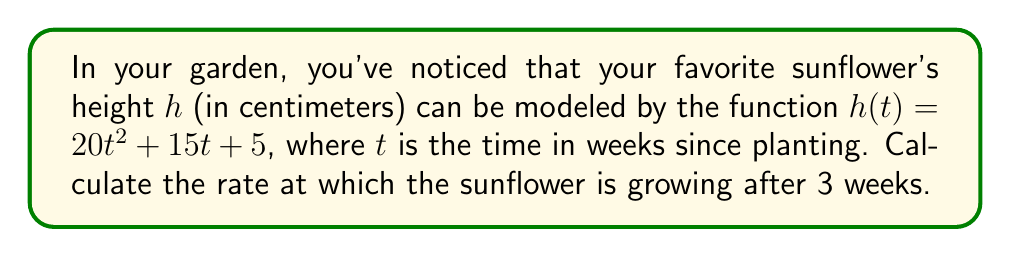Can you solve this math problem? To find the rate of growth at a specific time, we need to calculate the derivative of the height function and evaluate it at the given time.

1. The height function is given by:
   $$h(t) = 20t^2 + 15t + 5$$

2. To find the rate of change, we need to find $\frac{dh}{dt}$:
   $$\frac{dh}{dt} = 40t + 15$$

3. This derivative represents the instantaneous rate of growth at any time $t$.

4. We want to find the rate of growth after 3 weeks, so we need to evaluate $\frac{dh}{dt}$ at $t = 3$:
   $$\frac{dh}{dt}(3) = 40(3) + 15 = 120 + 15 = 135$$

5. Therefore, after 3 weeks, the sunflower is growing at a rate of 135 cm/week.
Answer: 135 cm/week 